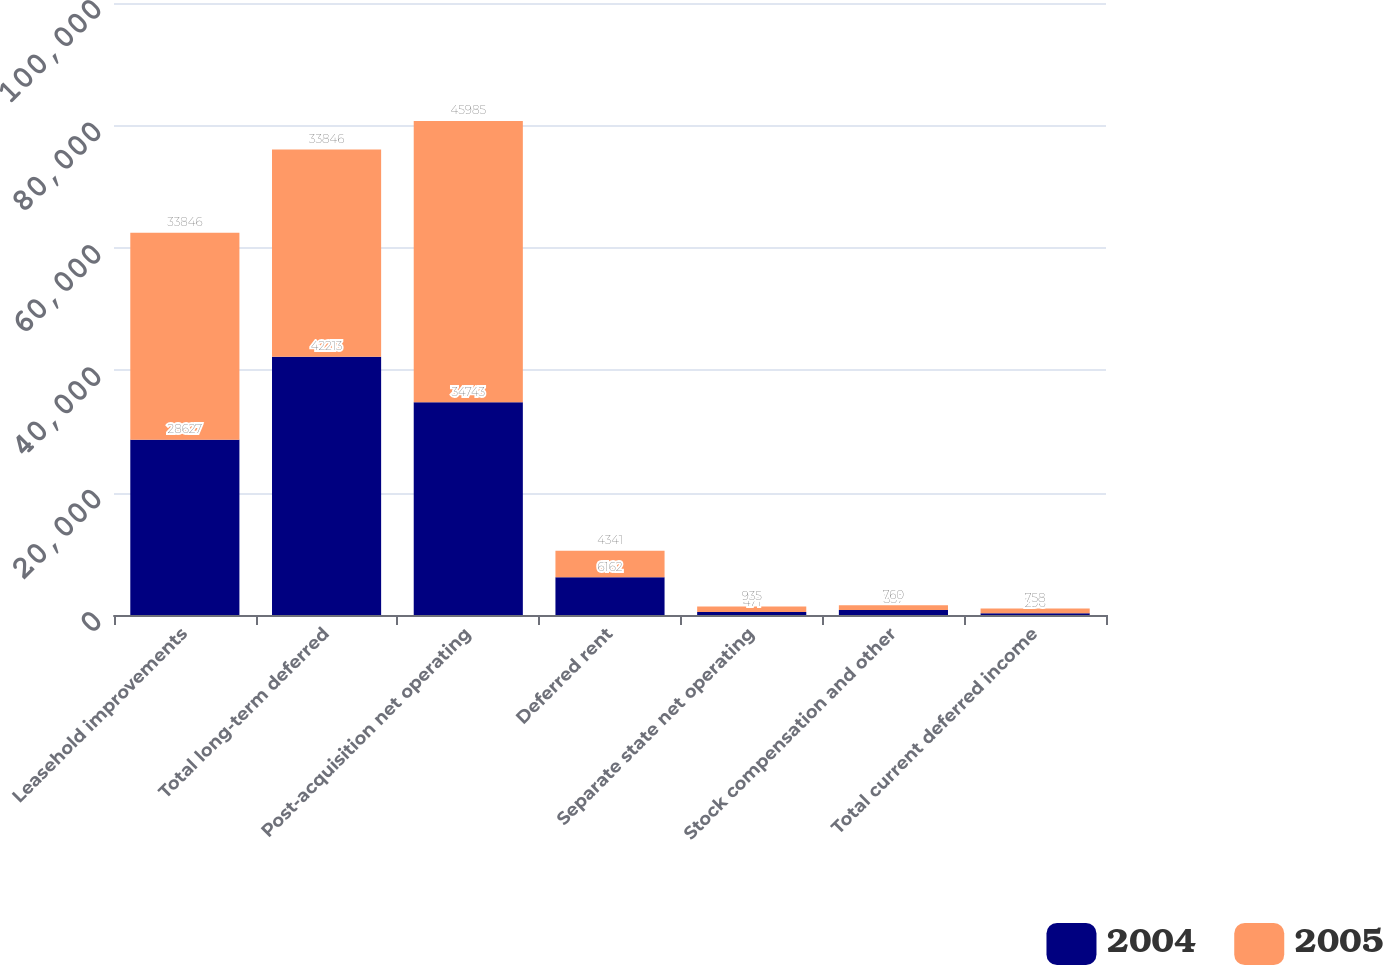<chart> <loc_0><loc_0><loc_500><loc_500><stacked_bar_chart><ecel><fcel>Leasehold improvements<fcel>Total long-term deferred<fcel>Post-acquisition net operating<fcel>Deferred rent<fcel>Separate state net operating<fcel>Stock compensation and other<fcel>Total current deferred income<nl><fcel>2004<fcel>28627<fcel>42213<fcel>34743<fcel>6162<fcel>471<fcel>837<fcel>296<nl><fcel>2005<fcel>33846<fcel>33846<fcel>45985<fcel>4341<fcel>935<fcel>760<fcel>758<nl></chart> 